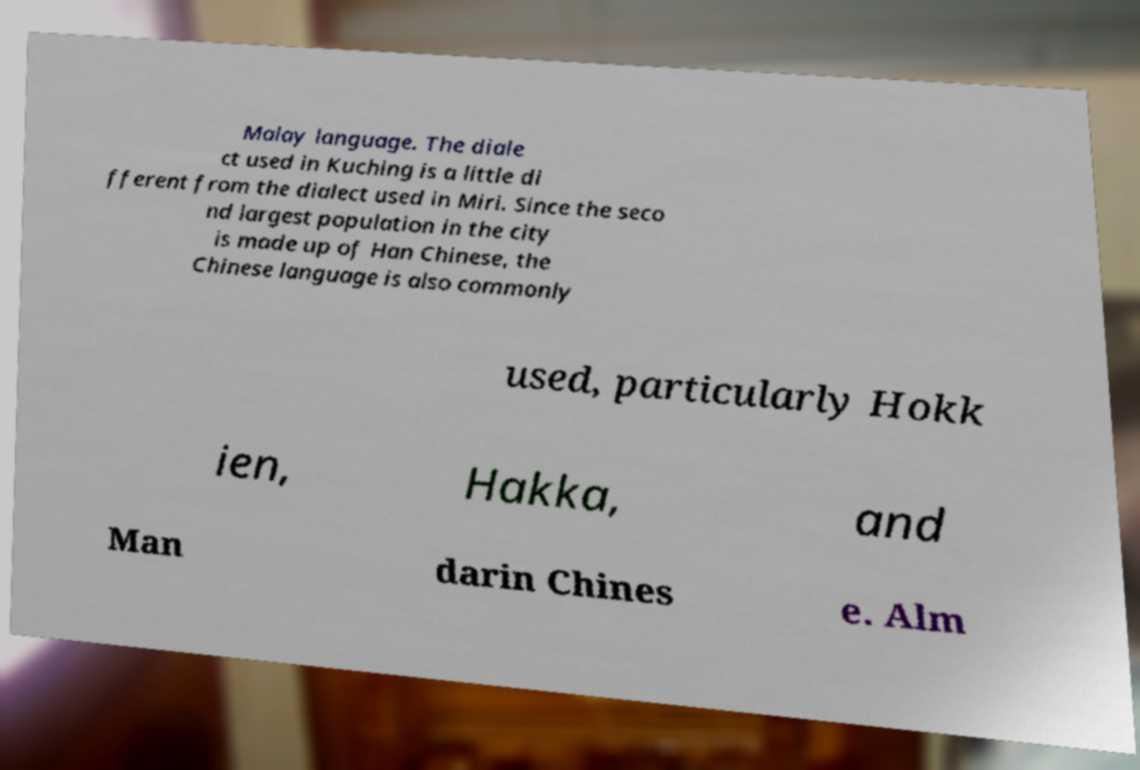Please identify and transcribe the text found in this image. Malay language. The diale ct used in Kuching is a little di fferent from the dialect used in Miri. Since the seco nd largest population in the city is made up of Han Chinese, the Chinese language is also commonly used, particularly Hokk ien, Hakka, and Man darin Chines e. Alm 